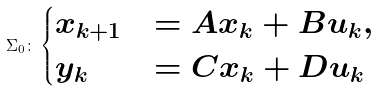<formula> <loc_0><loc_0><loc_500><loc_500>\Sigma _ { 0 } \colon \begin{cases} x _ { k + 1 } & = A x _ { k } + B u _ { k } , \\ y _ { k } & = C x _ { k } + D u _ { k } \end{cases}</formula> 